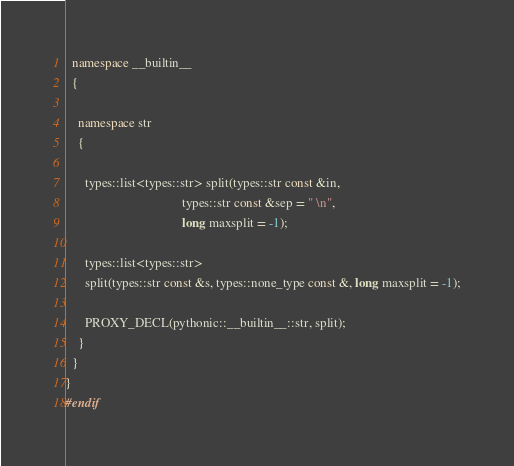Convert code to text. <code><loc_0><loc_0><loc_500><loc_500><_C++_>
  namespace __builtin__
  {

    namespace str
    {

      types::list<types::str> split(types::str const &in,
                                    types::str const &sep = " \n",
                                    long maxsplit = -1);

      types::list<types::str>
      split(types::str const &s, types::none_type const &, long maxsplit = -1);

      PROXY_DECL(pythonic::__builtin__::str, split);
    }
  }
}
#endif
</code> 